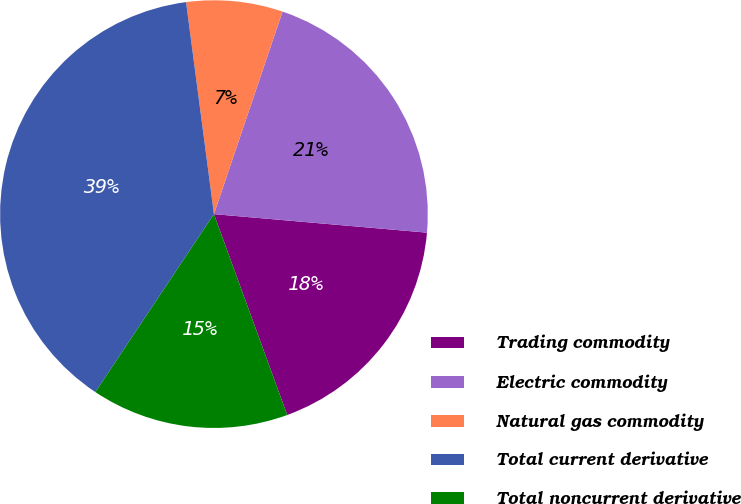Convert chart to OTSL. <chart><loc_0><loc_0><loc_500><loc_500><pie_chart><fcel>Trading commodity<fcel>Electric commodity<fcel>Natural gas commodity<fcel>Total current derivative<fcel>Total noncurrent derivative<nl><fcel>18.05%<fcel>21.18%<fcel>7.28%<fcel>38.56%<fcel>14.92%<nl></chart> 